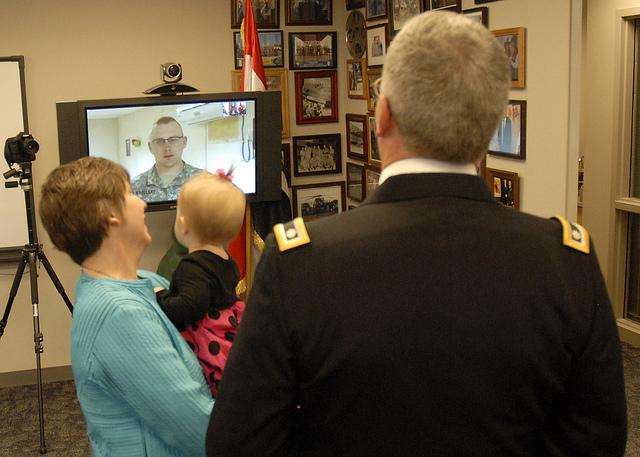What color is the skirt on the kid?
Short answer required. Pink. Why are they looking at a television?
Give a very brief answer. Video call. Where is the flag?
Write a very short answer. Behind tv. 